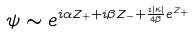Convert formula to latex. <formula><loc_0><loc_0><loc_500><loc_500>\psi \sim e ^ { i \alpha Z _ { + } + i \beta Z _ { - } + \frac { i | \kappa | } { 4 \beta } e ^ { Z _ { + } } }</formula> 